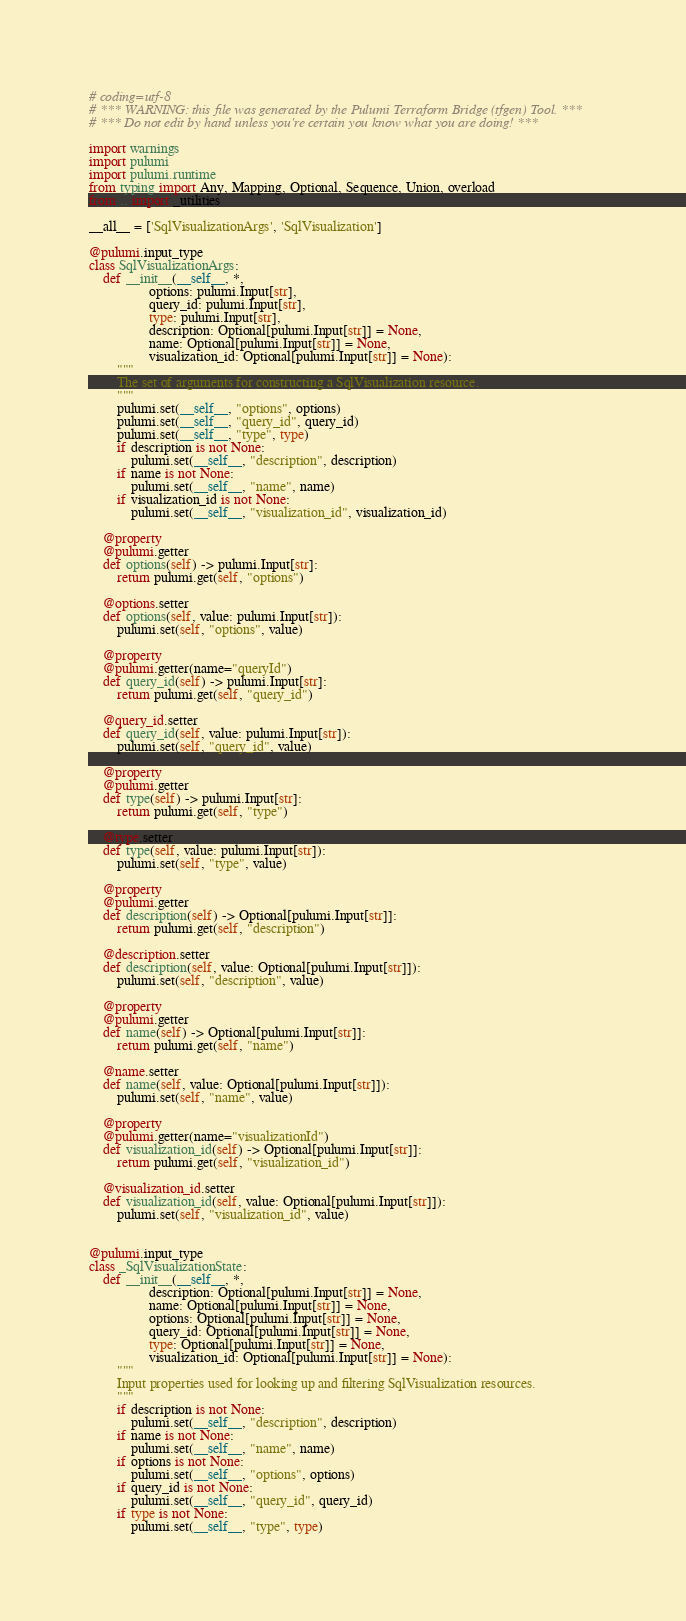Convert code to text. <code><loc_0><loc_0><loc_500><loc_500><_Python_># coding=utf-8
# *** WARNING: this file was generated by the Pulumi Terraform Bridge (tfgen) Tool. ***
# *** Do not edit by hand unless you're certain you know what you are doing! ***

import warnings
import pulumi
import pulumi.runtime
from typing import Any, Mapping, Optional, Sequence, Union, overload
from .. import _utilities

__all__ = ['SqlVisualizationArgs', 'SqlVisualization']

@pulumi.input_type
class SqlVisualizationArgs:
    def __init__(__self__, *,
                 options: pulumi.Input[str],
                 query_id: pulumi.Input[str],
                 type: pulumi.Input[str],
                 description: Optional[pulumi.Input[str]] = None,
                 name: Optional[pulumi.Input[str]] = None,
                 visualization_id: Optional[pulumi.Input[str]] = None):
        """
        The set of arguments for constructing a SqlVisualization resource.
        """
        pulumi.set(__self__, "options", options)
        pulumi.set(__self__, "query_id", query_id)
        pulumi.set(__self__, "type", type)
        if description is not None:
            pulumi.set(__self__, "description", description)
        if name is not None:
            pulumi.set(__self__, "name", name)
        if visualization_id is not None:
            pulumi.set(__self__, "visualization_id", visualization_id)

    @property
    @pulumi.getter
    def options(self) -> pulumi.Input[str]:
        return pulumi.get(self, "options")

    @options.setter
    def options(self, value: pulumi.Input[str]):
        pulumi.set(self, "options", value)

    @property
    @pulumi.getter(name="queryId")
    def query_id(self) -> pulumi.Input[str]:
        return pulumi.get(self, "query_id")

    @query_id.setter
    def query_id(self, value: pulumi.Input[str]):
        pulumi.set(self, "query_id", value)

    @property
    @pulumi.getter
    def type(self) -> pulumi.Input[str]:
        return pulumi.get(self, "type")

    @type.setter
    def type(self, value: pulumi.Input[str]):
        pulumi.set(self, "type", value)

    @property
    @pulumi.getter
    def description(self) -> Optional[pulumi.Input[str]]:
        return pulumi.get(self, "description")

    @description.setter
    def description(self, value: Optional[pulumi.Input[str]]):
        pulumi.set(self, "description", value)

    @property
    @pulumi.getter
    def name(self) -> Optional[pulumi.Input[str]]:
        return pulumi.get(self, "name")

    @name.setter
    def name(self, value: Optional[pulumi.Input[str]]):
        pulumi.set(self, "name", value)

    @property
    @pulumi.getter(name="visualizationId")
    def visualization_id(self) -> Optional[pulumi.Input[str]]:
        return pulumi.get(self, "visualization_id")

    @visualization_id.setter
    def visualization_id(self, value: Optional[pulumi.Input[str]]):
        pulumi.set(self, "visualization_id", value)


@pulumi.input_type
class _SqlVisualizationState:
    def __init__(__self__, *,
                 description: Optional[pulumi.Input[str]] = None,
                 name: Optional[pulumi.Input[str]] = None,
                 options: Optional[pulumi.Input[str]] = None,
                 query_id: Optional[pulumi.Input[str]] = None,
                 type: Optional[pulumi.Input[str]] = None,
                 visualization_id: Optional[pulumi.Input[str]] = None):
        """
        Input properties used for looking up and filtering SqlVisualization resources.
        """
        if description is not None:
            pulumi.set(__self__, "description", description)
        if name is not None:
            pulumi.set(__self__, "name", name)
        if options is not None:
            pulumi.set(__self__, "options", options)
        if query_id is not None:
            pulumi.set(__self__, "query_id", query_id)
        if type is not None:
            pulumi.set(__self__, "type", type)</code> 